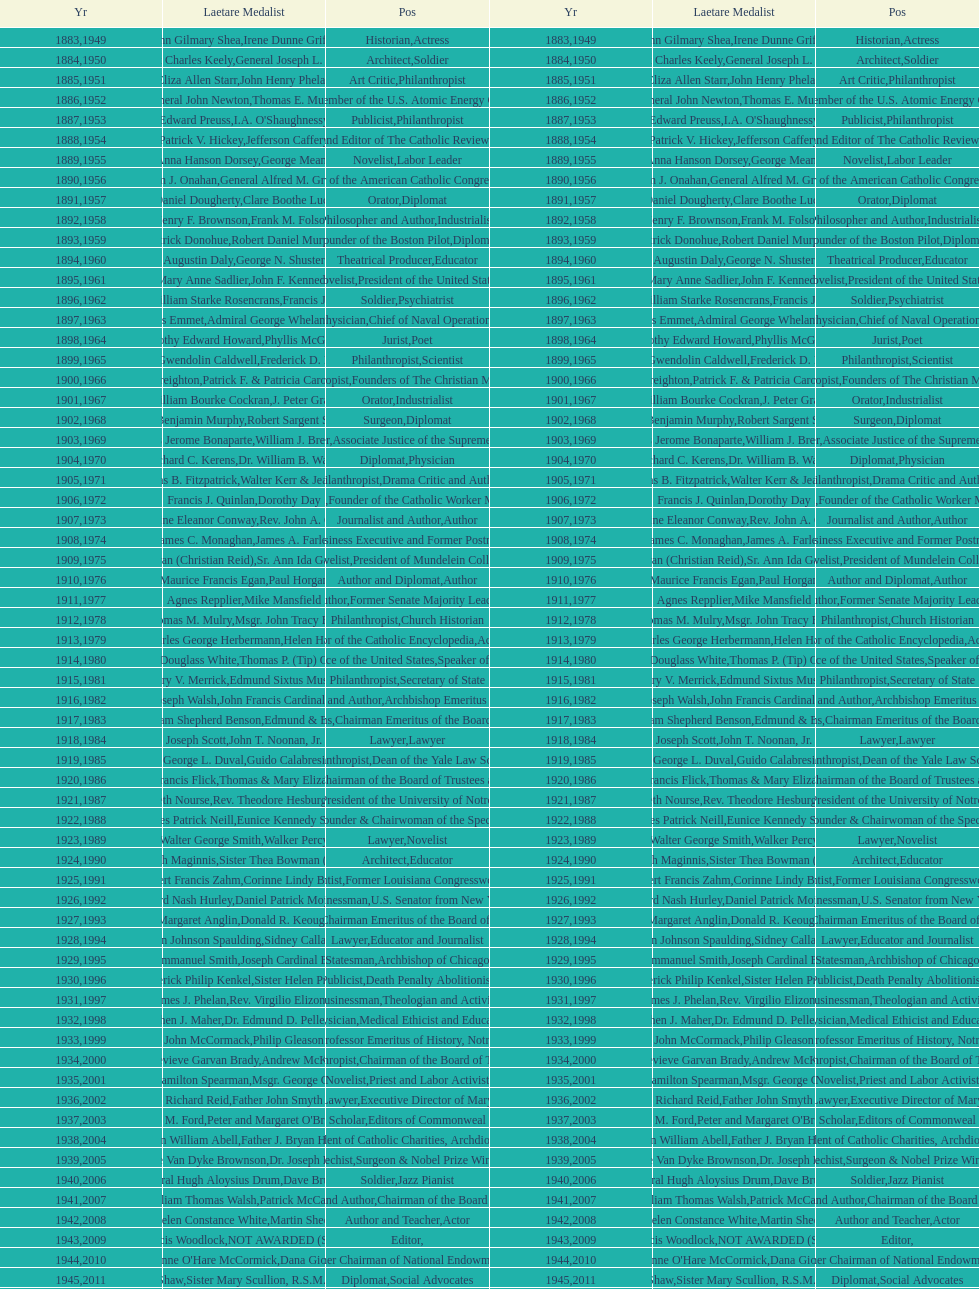Who was the previous winner before john henry phelan in 1951? General Joseph L. Collins. 